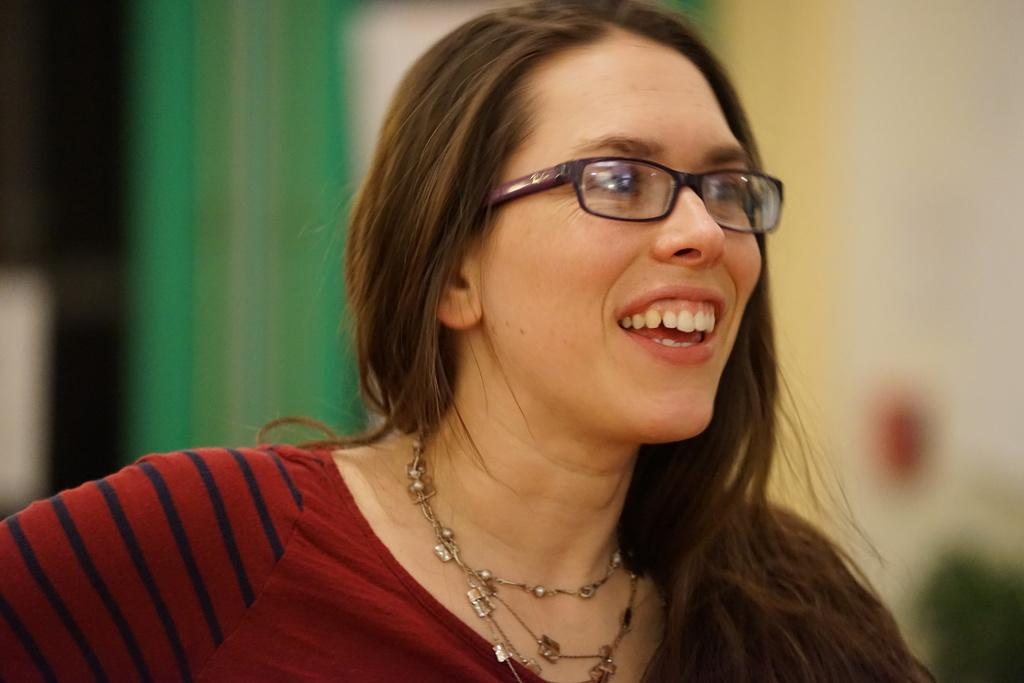Who is the main subject in the image? There is a girl in the image. What is the girl's expression in the image? The girl is smiling in the image. What accessory is the girl wearing in the image? The girl is wearing spectacles in the image. What is the woman wearing in the image? The woman is wearing a red dress and a chain around her neck in the image. What type of wound can be seen on the girl's arm in the image? There is no wound visible on the girl's arm in the image. What is the girl using to drink from the straw in the image? There is no straw present in the image. 